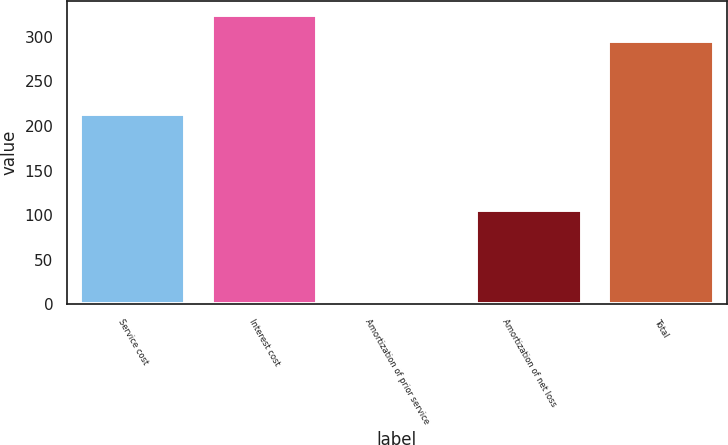Convert chart to OTSL. <chart><loc_0><loc_0><loc_500><loc_500><bar_chart><fcel>Service cost<fcel>Interest cost<fcel>Amortization of prior service<fcel>Amortization of net loss<fcel>Total<nl><fcel>213<fcel>324.3<fcel>3<fcel>106<fcel>295<nl></chart> 